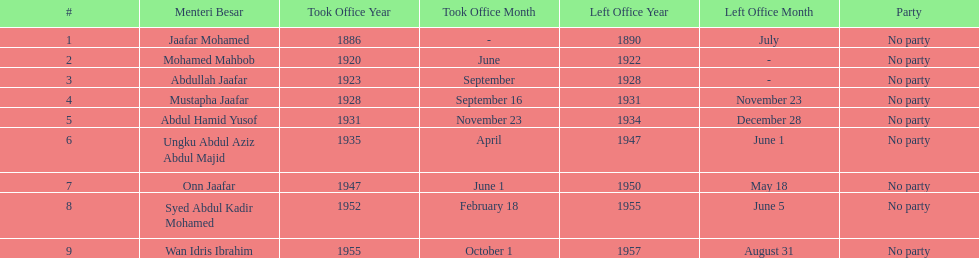What is the number of menteri besars that there have been during the pre-independence period? 9. 